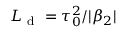<formula> <loc_0><loc_0><loc_500><loc_500>L _ { d } = \tau _ { 0 } ^ { 2 } / | \beta _ { 2 } |</formula> 